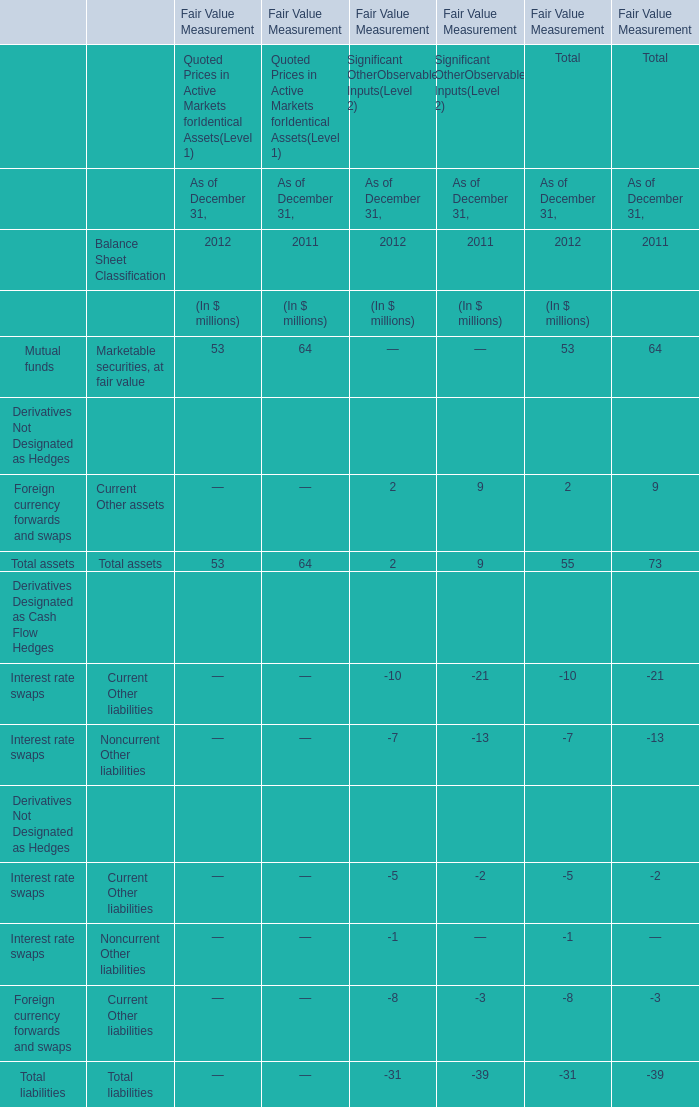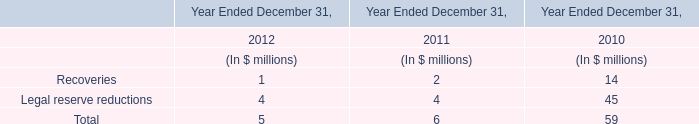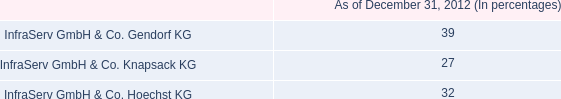What was the total amount of liabilities in 2011 / forTotal? (in million) 
Computations: (((-21 - 13) - 2) - 3)
Answer: -39.0. 